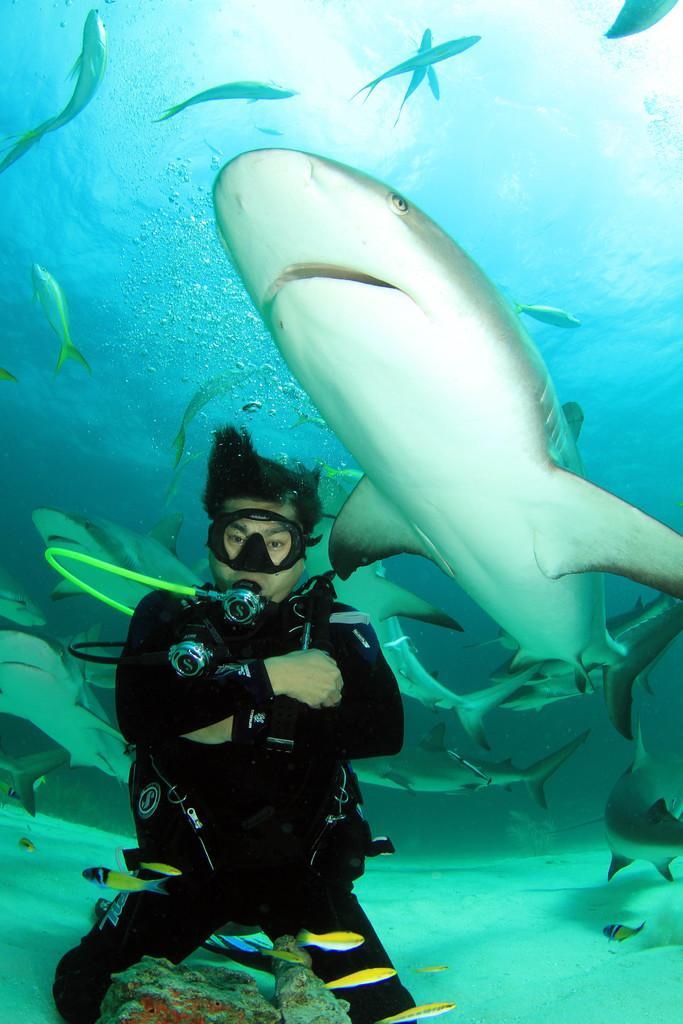Could you give a brief overview of what you see in this image? This image is taken under water. There is a person wearing a swimsuit. There are fishes. 